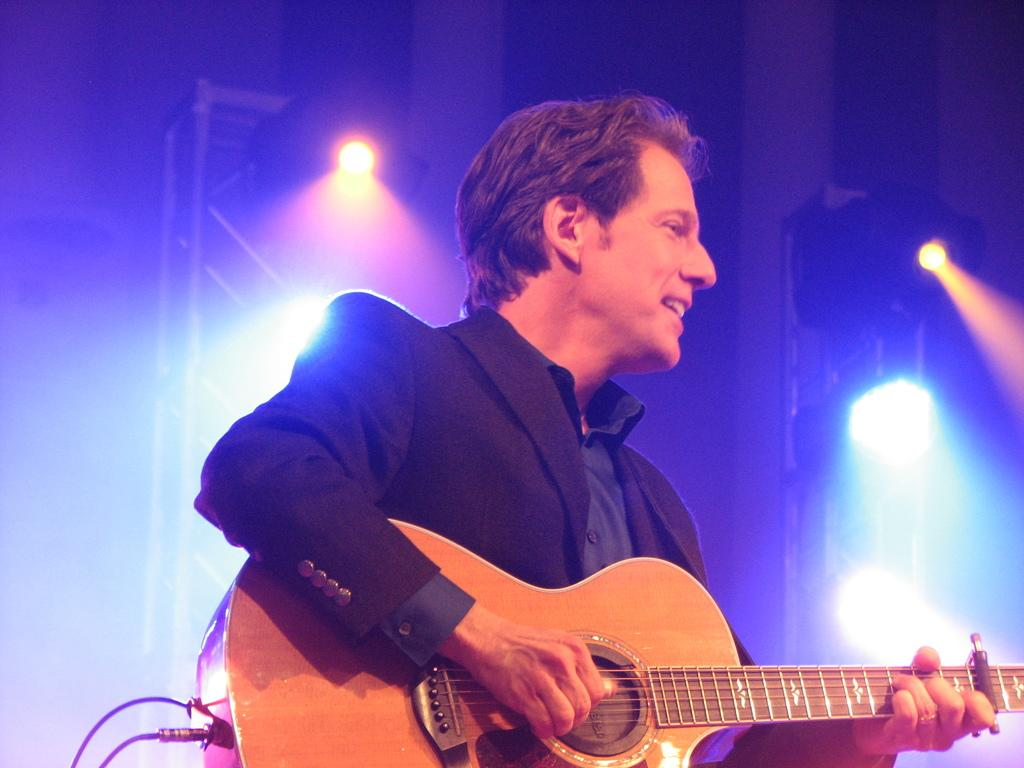What objects can be seen in the image? There are lights and a man holding a guitar in the image. Can you describe the man in the image? The man in the image is holding a guitar. What might the man be doing in the image? The man might be playing the guitar, as he is holding it. Where is the grandfather sitting with the bottle of jellyfish in the image? There is no grandfather or bottle of jellyfish present in the image. 